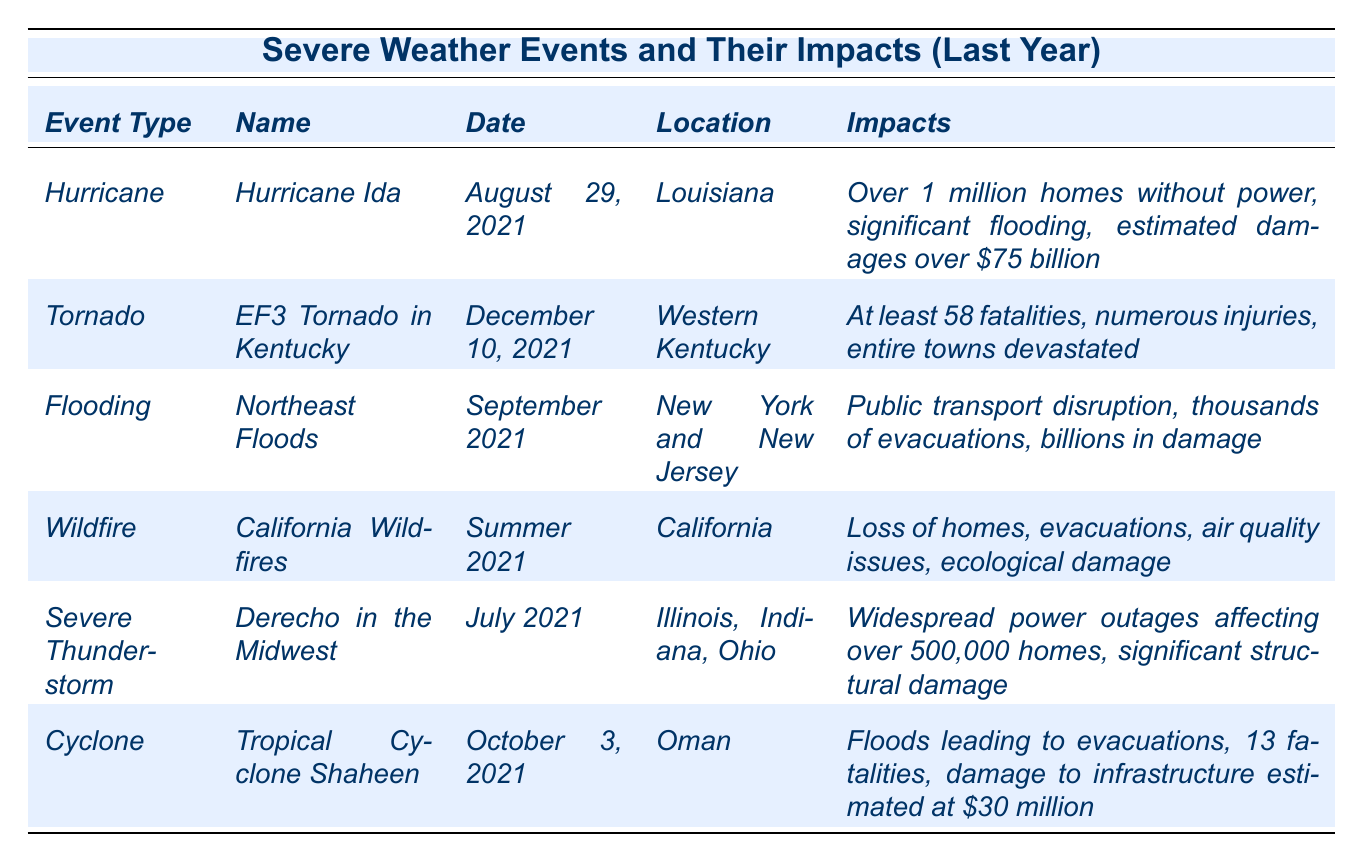What type of severe weather event caused at least 58 fatalities? The table indicates that the EF3 Tornado in Kentucky resulted in at least 58 fatalities.
Answer: EF3 Tornado Which event had the highest estimated damages? According to the table, Hurricane Ida had estimated damages over $75 billion, which is the highest among all listed events.
Answer: Hurricane Ida How many homes were affected by the Derecho in the Midwest? The table states that the Derecho caused widespread power outages affecting over 500,000 homes.
Answer: 500,000 homes Was there a flood event reported in the table? Yes, the Northeast Floods are categorized under flooding, as mentioned in the table.
Answer: Yes Which event occurred last in the table? The table shows that the Tropical Cyclone Shaheen occurred on October 3, 2021, which is the latest date listed.
Answer: Tropical Cyclone Shaheen What is the combined estimated damages from the Hurricane Ida and the Tropical Cyclone Shaheen? Hurricane Ida has damages of over $75 billion, and Tropical Cyclone Shaheen's damages are estimated at $30 million, so combined they would be $75 billion + $30 million, which equals $75.03 billion.
Answer: $75.03 billion Which event caused the largest area of land to be burned? The California Wildfires burned 2 million acres, as indicated in the table, which is the largest area compared to the other events.
Answer: 2 million acres What was the wind speed of the EF3 Tornado reported in Kentucky? The table lists the wind speed of the EF3 Tornado in Kentucky as 165 mph.
Answer: 165 mph How many events occurred in the summer of 2021? The table shows both the California Wildfires (Summer 2021) and the Derecho in the Midwest (July 2021), totaling two events in the summer of 2021.
Answer: 2 events Did the floods lead to evacuations according to the table? Yes, the Northeast Floods mentioned that thousands were evacuated due to the flooding, confirming that evacuations occurred.
Answer: Yes 